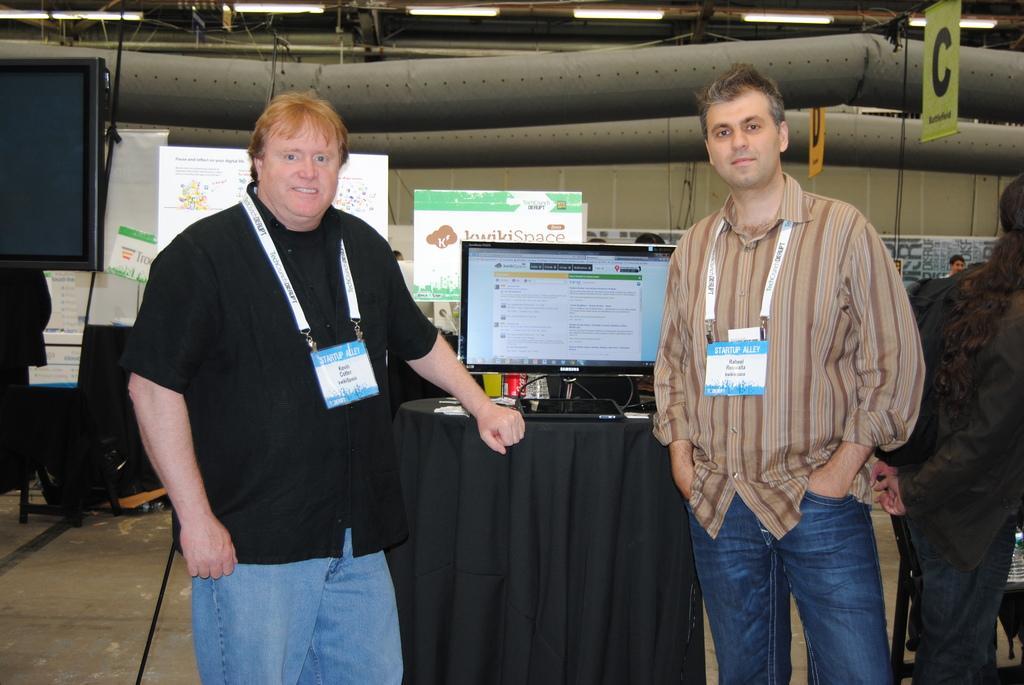How would you summarize this image in a sentence or two? On the left side a man is standing, he wore black color shirt, blue color trouser. In the middle there is a desktop. On the right side another man is standing, he wore shirt, trouser and an ID card. At the top there are lights to the roof. 